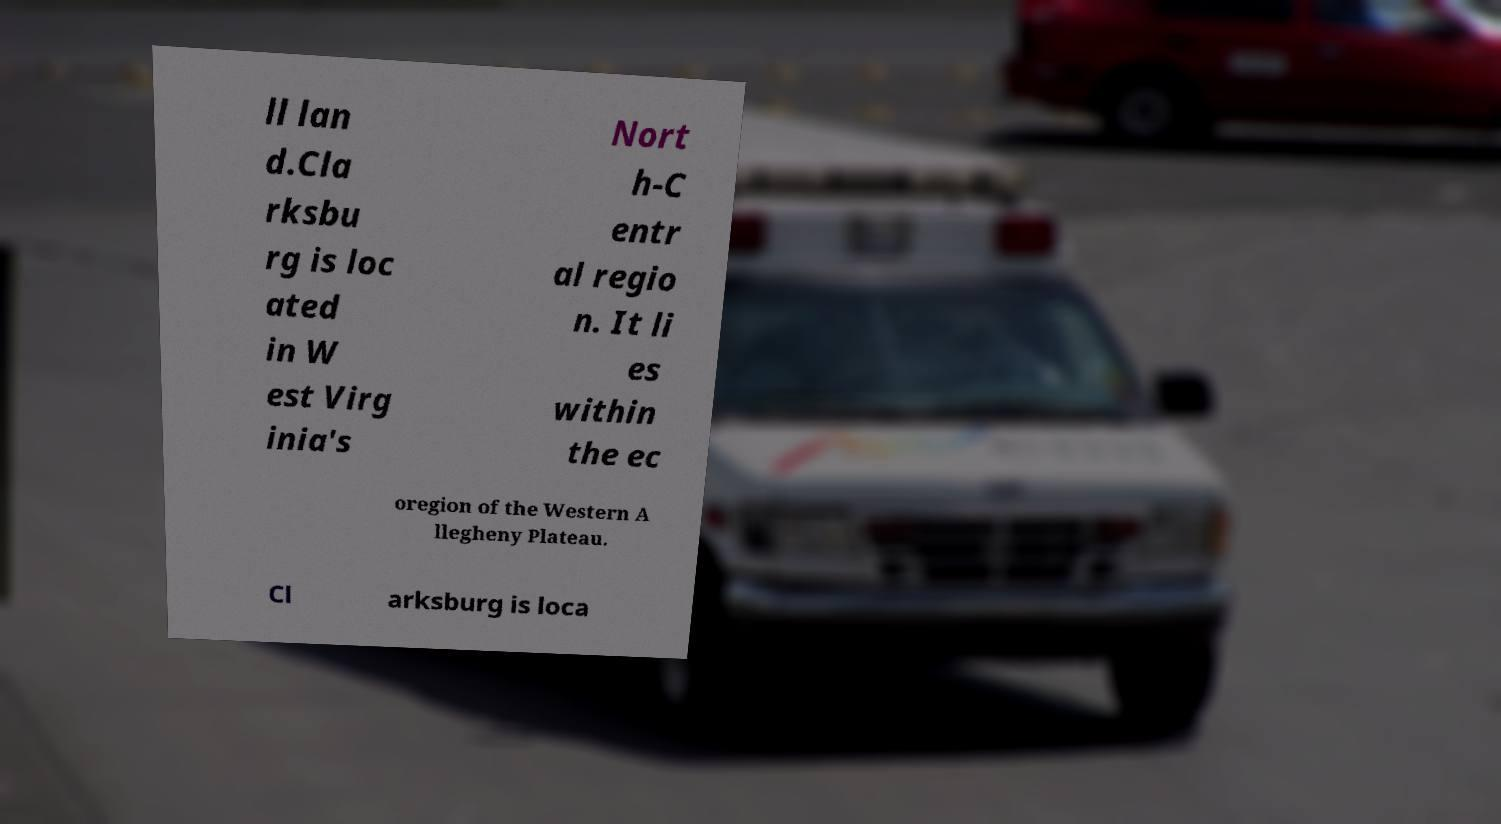Please read and relay the text visible in this image. What does it say? ll lan d.Cla rksbu rg is loc ated in W est Virg inia's Nort h-C entr al regio n. It li es within the ec oregion of the Western A llegheny Plateau. Cl arksburg is loca 